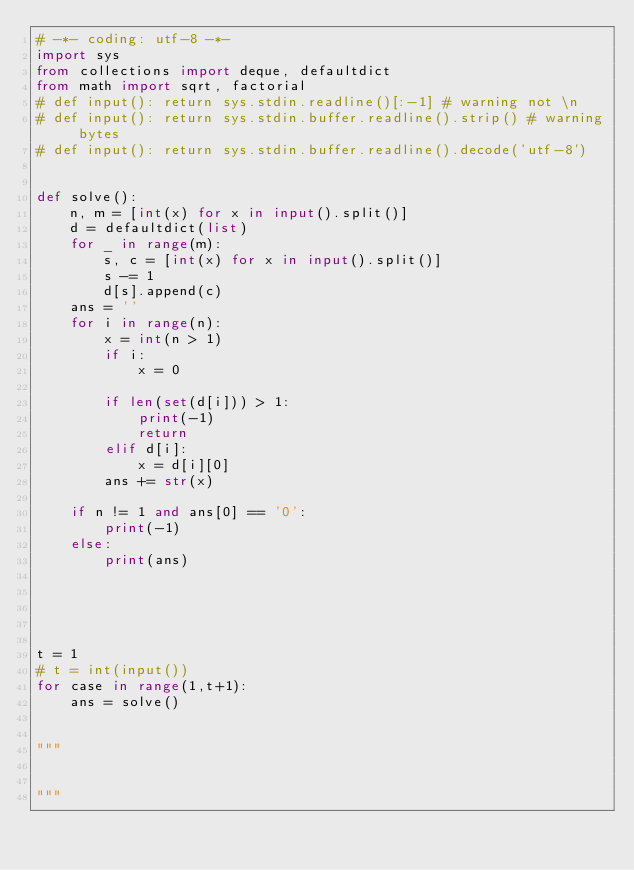Convert code to text. <code><loc_0><loc_0><loc_500><loc_500><_Python_># -*- coding: utf-8 -*-
import sys
from collections import deque, defaultdict
from math import sqrt, factorial
# def input(): return sys.stdin.readline()[:-1] # warning not \n
# def input(): return sys.stdin.buffer.readline().strip() # warning bytes
# def input(): return sys.stdin.buffer.readline().decode('utf-8')


def solve():
    n, m = [int(x) for x in input().split()]
    d = defaultdict(list)
    for _ in range(m):
        s, c = [int(x) for x in input().split()]
        s -= 1
        d[s].append(c)
    ans = ''
    for i in range(n):
        x = int(n > 1)
        if i:
            x = 0
        
        if len(set(d[i])) > 1:
            print(-1)
            return
        elif d[i]:
            x = d[i][0]
        ans += str(x)

    if n != 1 and ans[0] == '0':
        print(-1)
    else:
        print(ans)



    

t = 1
# t = int(input())
for case in range(1,t+1):
    ans = solve()


"""


"""
</code> 